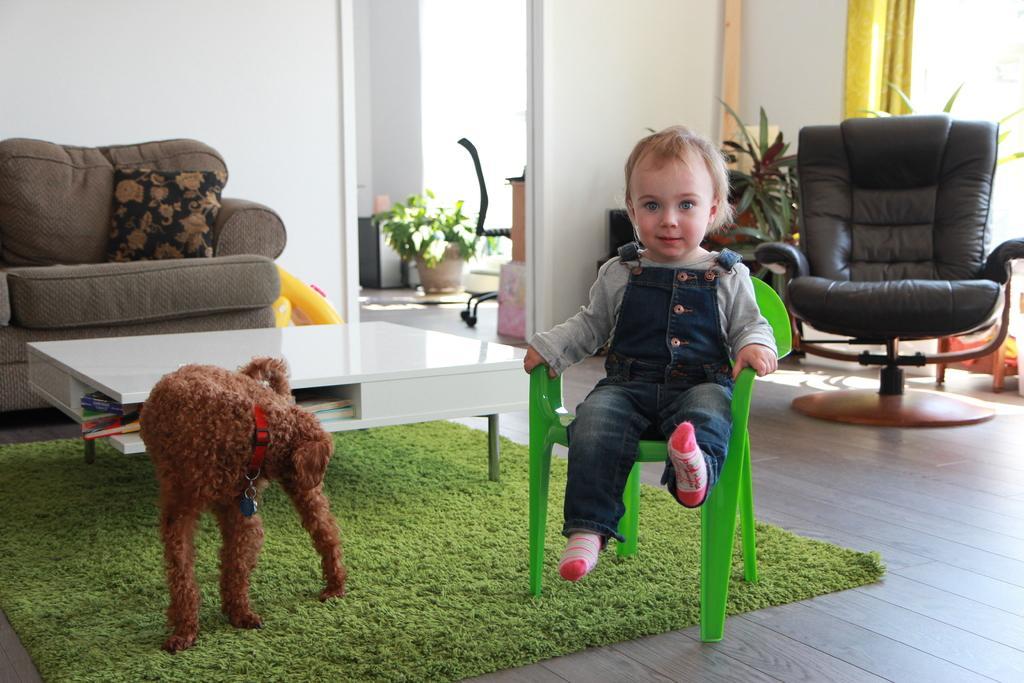How would you summarize this image in a sentence or two? The picture is clicked inside a house. A small kid is sitting inside a chair with a brown dog beside him,in the background we observe brown color sofa and a white color table also a black color chair. In the background the wall is white in color. 